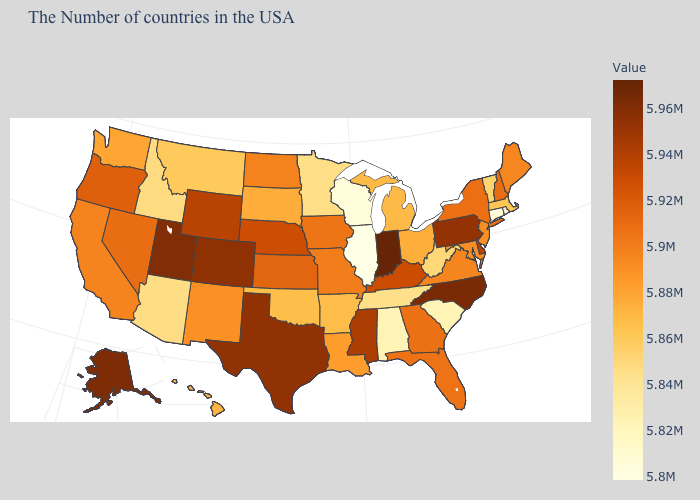Does the map have missing data?
Quick response, please. No. Does Pennsylvania have a lower value than Indiana?
Be succinct. Yes. Among the states that border Wyoming , does Montana have the highest value?
Quick response, please. No. Which states have the lowest value in the USA?
Short answer required. Illinois. Does Idaho have the lowest value in the USA?
Be succinct. No. Does Tennessee have the highest value in the South?
Keep it brief. No. Among the states that border Wisconsin , does Minnesota have the lowest value?
Be succinct. No. Which states hav the highest value in the Northeast?
Give a very brief answer. Pennsylvania. 